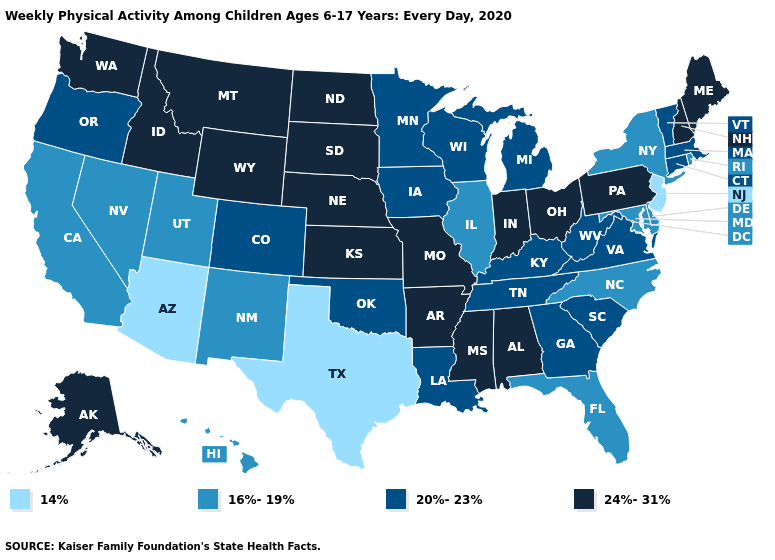Which states have the highest value in the USA?
Keep it brief. Alabama, Alaska, Arkansas, Idaho, Indiana, Kansas, Maine, Mississippi, Missouri, Montana, Nebraska, New Hampshire, North Dakota, Ohio, Pennsylvania, South Dakota, Washington, Wyoming. What is the highest value in the West ?
Concise answer only. 24%-31%. Does Michigan have the lowest value in the USA?
Answer briefly. No. Name the states that have a value in the range 24%-31%?
Give a very brief answer. Alabama, Alaska, Arkansas, Idaho, Indiana, Kansas, Maine, Mississippi, Missouri, Montana, Nebraska, New Hampshire, North Dakota, Ohio, Pennsylvania, South Dakota, Washington, Wyoming. Name the states that have a value in the range 20%-23%?
Quick response, please. Colorado, Connecticut, Georgia, Iowa, Kentucky, Louisiana, Massachusetts, Michigan, Minnesota, Oklahoma, Oregon, South Carolina, Tennessee, Vermont, Virginia, West Virginia, Wisconsin. Does Idaho have a higher value than Virginia?
Answer briefly. Yes. Among the states that border South Dakota , which have the lowest value?
Quick response, please. Iowa, Minnesota. What is the highest value in the South ?
Write a very short answer. 24%-31%. Which states have the highest value in the USA?
Be succinct. Alabama, Alaska, Arkansas, Idaho, Indiana, Kansas, Maine, Mississippi, Missouri, Montana, Nebraska, New Hampshire, North Dakota, Ohio, Pennsylvania, South Dakota, Washington, Wyoming. What is the highest value in the MidWest ?
Short answer required. 24%-31%. Does Massachusetts have a higher value than North Dakota?
Answer briefly. No. Name the states that have a value in the range 14%?
Keep it brief. Arizona, New Jersey, Texas. What is the lowest value in states that border Ohio?
Answer briefly. 20%-23%. Which states have the lowest value in the USA?
Short answer required. Arizona, New Jersey, Texas. Does Connecticut have the same value as Colorado?
Quick response, please. Yes. 